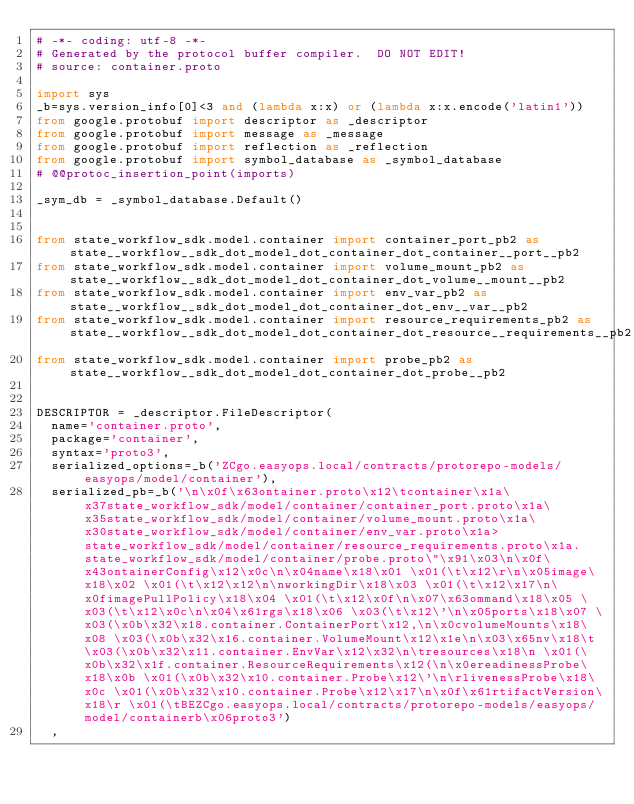Convert code to text. <code><loc_0><loc_0><loc_500><loc_500><_Python_># -*- coding: utf-8 -*-
# Generated by the protocol buffer compiler.  DO NOT EDIT!
# source: container.proto

import sys
_b=sys.version_info[0]<3 and (lambda x:x) or (lambda x:x.encode('latin1'))
from google.protobuf import descriptor as _descriptor
from google.protobuf import message as _message
from google.protobuf import reflection as _reflection
from google.protobuf import symbol_database as _symbol_database
# @@protoc_insertion_point(imports)

_sym_db = _symbol_database.Default()


from state_workflow_sdk.model.container import container_port_pb2 as state__workflow__sdk_dot_model_dot_container_dot_container__port__pb2
from state_workflow_sdk.model.container import volume_mount_pb2 as state__workflow__sdk_dot_model_dot_container_dot_volume__mount__pb2
from state_workflow_sdk.model.container import env_var_pb2 as state__workflow__sdk_dot_model_dot_container_dot_env__var__pb2
from state_workflow_sdk.model.container import resource_requirements_pb2 as state__workflow__sdk_dot_model_dot_container_dot_resource__requirements__pb2
from state_workflow_sdk.model.container import probe_pb2 as state__workflow__sdk_dot_model_dot_container_dot_probe__pb2


DESCRIPTOR = _descriptor.FileDescriptor(
  name='container.proto',
  package='container',
  syntax='proto3',
  serialized_options=_b('ZCgo.easyops.local/contracts/protorepo-models/easyops/model/container'),
  serialized_pb=_b('\n\x0f\x63ontainer.proto\x12\tcontainer\x1a\x37state_workflow_sdk/model/container/container_port.proto\x1a\x35state_workflow_sdk/model/container/volume_mount.proto\x1a\x30state_workflow_sdk/model/container/env_var.proto\x1a>state_workflow_sdk/model/container/resource_requirements.proto\x1a.state_workflow_sdk/model/container/probe.proto\"\x91\x03\n\x0f\x43ontainerConfig\x12\x0c\n\x04name\x18\x01 \x01(\t\x12\r\n\x05image\x18\x02 \x01(\t\x12\x12\n\nworkingDir\x18\x03 \x01(\t\x12\x17\n\x0fimagePullPolicy\x18\x04 \x01(\t\x12\x0f\n\x07\x63ommand\x18\x05 \x03(\t\x12\x0c\n\x04\x61rgs\x18\x06 \x03(\t\x12\'\n\x05ports\x18\x07 \x03(\x0b\x32\x18.container.ContainerPort\x12,\n\x0cvolumeMounts\x18\x08 \x03(\x0b\x32\x16.container.VolumeMount\x12\x1e\n\x03\x65nv\x18\t \x03(\x0b\x32\x11.container.EnvVar\x12\x32\n\tresources\x18\n \x01(\x0b\x32\x1f.container.ResourceRequirements\x12(\n\x0ereadinessProbe\x18\x0b \x01(\x0b\x32\x10.container.Probe\x12\'\n\rlivenessProbe\x18\x0c \x01(\x0b\x32\x10.container.Probe\x12\x17\n\x0f\x61rtifactVersion\x18\r \x01(\tBEZCgo.easyops.local/contracts/protorepo-models/easyops/model/containerb\x06proto3')
  ,</code> 